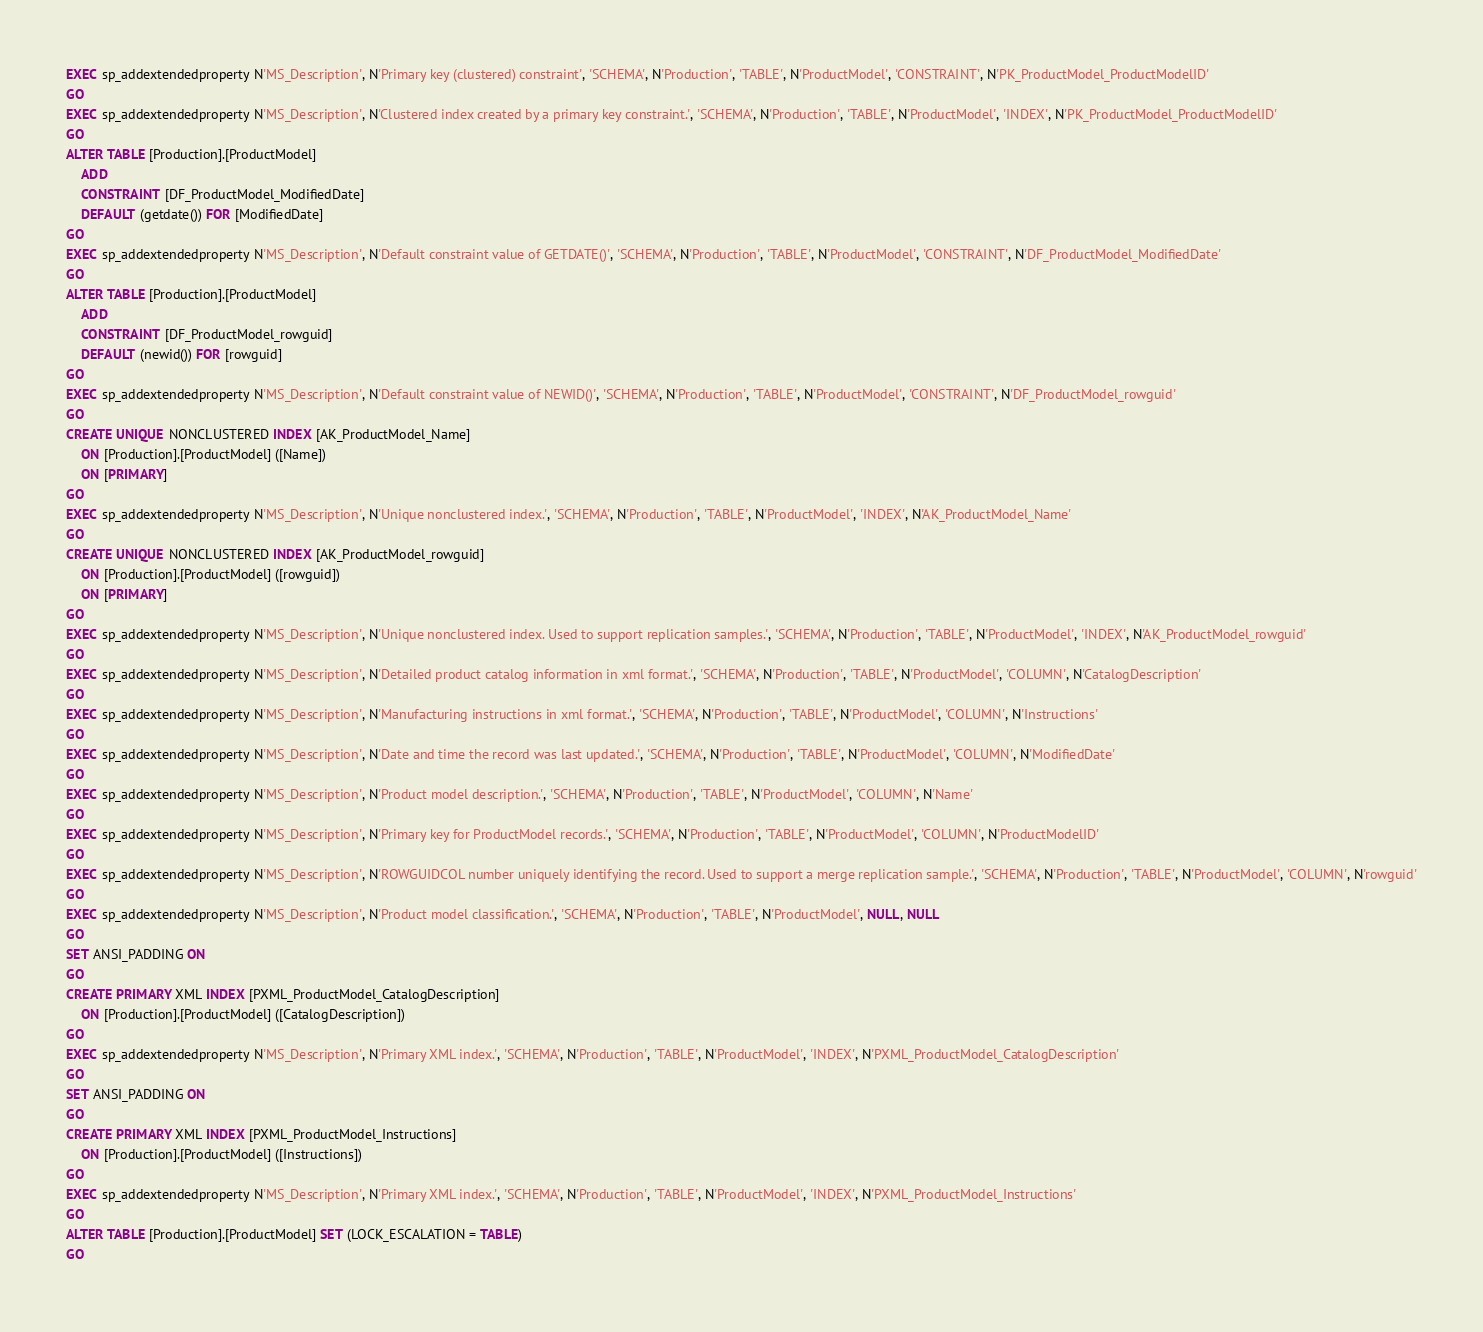Convert code to text. <code><loc_0><loc_0><loc_500><loc_500><_SQL_>EXEC sp_addextendedproperty N'MS_Description', N'Primary key (clustered) constraint', 'SCHEMA', N'Production', 'TABLE', N'ProductModel', 'CONSTRAINT', N'PK_ProductModel_ProductModelID'
GO
EXEC sp_addextendedproperty N'MS_Description', N'Clustered index created by a primary key constraint.', 'SCHEMA', N'Production', 'TABLE', N'ProductModel', 'INDEX', N'PK_ProductModel_ProductModelID'
GO
ALTER TABLE [Production].[ProductModel]
	ADD
	CONSTRAINT [DF_ProductModel_ModifiedDate]
	DEFAULT (getdate()) FOR [ModifiedDate]
GO
EXEC sp_addextendedproperty N'MS_Description', N'Default constraint value of GETDATE()', 'SCHEMA', N'Production', 'TABLE', N'ProductModel', 'CONSTRAINT', N'DF_ProductModel_ModifiedDate'
GO
ALTER TABLE [Production].[ProductModel]
	ADD
	CONSTRAINT [DF_ProductModel_rowguid]
	DEFAULT (newid()) FOR [rowguid]
GO
EXEC sp_addextendedproperty N'MS_Description', N'Default constraint value of NEWID()', 'SCHEMA', N'Production', 'TABLE', N'ProductModel', 'CONSTRAINT', N'DF_ProductModel_rowguid'
GO
CREATE UNIQUE NONCLUSTERED INDEX [AK_ProductModel_Name]
	ON [Production].[ProductModel] ([Name])
	ON [PRIMARY]
GO
EXEC sp_addextendedproperty N'MS_Description', N'Unique nonclustered index.', 'SCHEMA', N'Production', 'TABLE', N'ProductModel', 'INDEX', N'AK_ProductModel_Name'
GO
CREATE UNIQUE NONCLUSTERED INDEX [AK_ProductModel_rowguid]
	ON [Production].[ProductModel] ([rowguid])
	ON [PRIMARY]
GO
EXEC sp_addextendedproperty N'MS_Description', N'Unique nonclustered index. Used to support replication samples.', 'SCHEMA', N'Production', 'TABLE', N'ProductModel', 'INDEX', N'AK_ProductModel_rowguid'
GO
EXEC sp_addextendedproperty N'MS_Description', N'Detailed product catalog information in xml format.', 'SCHEMA', N'Production', 'TABLE', N'ProductModel', 'COLUMN', N'CatalogDescription'
GO
EXEC sp_addextendedproperty N'MS_Description', N'Manufacturing instructions in xml format.', 'SCHEMA', N'Production', 'TABLE', N'ProductModel', 'COLUMN', N'Instructions'
GO
EXEC sp_addextendedproperty N'MS_Description', N'Date and time the record was last updated.', 'SCHEMA', N'Production', 'TABLE', N'ProductModel', 'COLUMN', N'ModifiedDate'
GO
EXEC sp_addextendedproperty N'MS_Description', N'Product model description.', 'SCHEMA', N'Production', 'TABLE', N'ProductModel', 'COLUMN', N'Name'
GO
EXEC sp_addextendedproperty N'MS_Description', N'Primary key for ProductModel records.', 'SCHEMA', N'Production', 'TABLE', N'ProductModel', 'COLUMN', N'ProductModelID'
GO
EXEC sp_addextendedproperty N'MS_Description', N'ROWGUIDCOL number uniquely identifying the record. Used to support a merge replication sample.', 'SCHEMA', N'Production', 'TABLE', N'ProductModel', 'COLUMN', N'rowguid'
GO
EXEC sp_addextendedproperty N'MS_Description', N'Product model classification.', 'SCHEMA', N'Production', 'TABLE', N'ProductModel', NULL, NULL
GO
SET ANSI_PADDING ON
GO
CREATE PRIMARY XML INDEX [PXML_ProductModel_CatalogDescription]
	ON [Production].[ProductModel] ([CatalogDescription])
GO
EXEC sp_addextendedproperty N'MS_Description', N'Primary XML index.', 'SCHEMA', N'Production', 'TABLE', N'ProductModel', 'INDEX', N'PXML_ProductModel_CatalogDescription'
GO
SET ANSI_PADDING ON
GO
CREATE PRIMARY XML INDEX [PXML_ProductModel_Instructions]
	ON [Production].[ProductModel] ([Instructions])
GO
EXEC sp_addextendedproperty N'MS_Description', N'Primary XML index.', 'SCHEMA', N'Production', 'TABLE', N'ProductModel', 'INDEX', N'PXML_ProductModel_Instructions'
GO
ALTER TABLE [Production].[ProductModel] SET (LOCK_ESCALATION = TABLE)
GO
</code> 